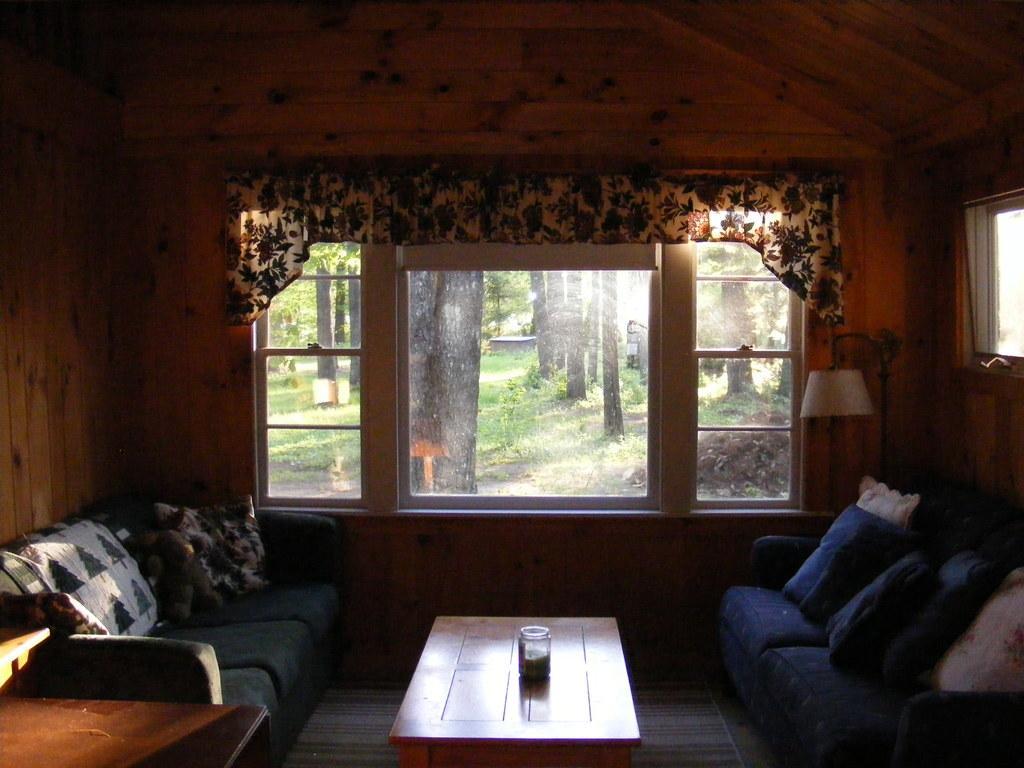Could you give a brief overview of what you see in this image? In the middle of the image there is a grass and trees. Bottom right side of the image there is a couch. Behind the couch there is a lamp. Top right side of the image there is a roof. Top left side of the image there is a wall. Bottom left side of the image there is a couch. In the middle of the image there is a table. On the table there is a cup. 